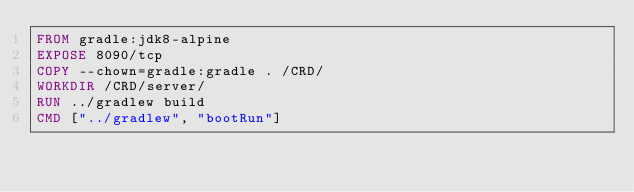Convert code to text. <code><loc_0><loc_0><loc_500><loc_500><_Dockerfile_>FROM gradle:jdk8-alpine
EXPOSE 8090/tcp
COPY --chown=gradle:gradle . /CRD/
WORKDIR /CRD/server/
RUN ../gradlew build
CMD ["../gradlew", "bootRun"]
</code> 